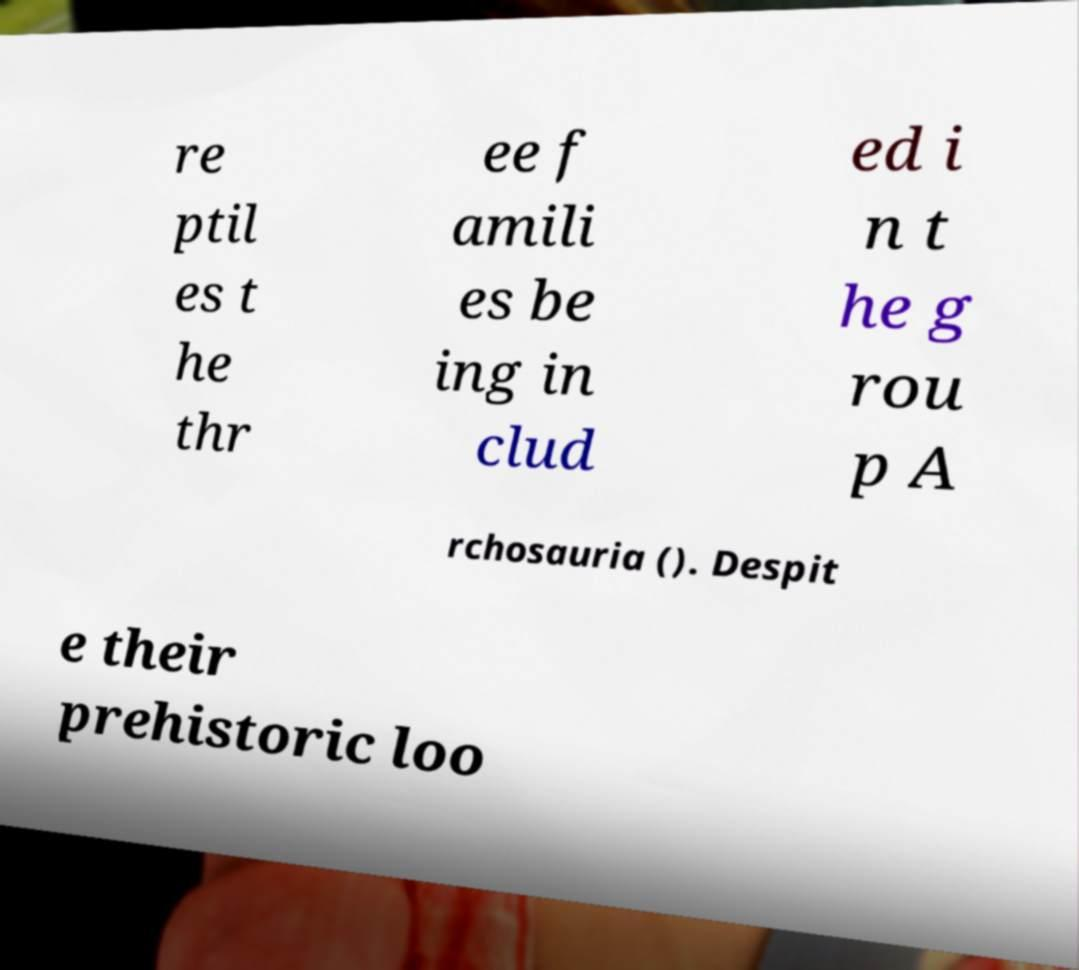I need the written content from this picture converted into text. Can you do that? re ptil es t he thr ee f amili es be ing in clud ed i n t he g rou p A rchosauria (). Despit e their prehistoric loo 